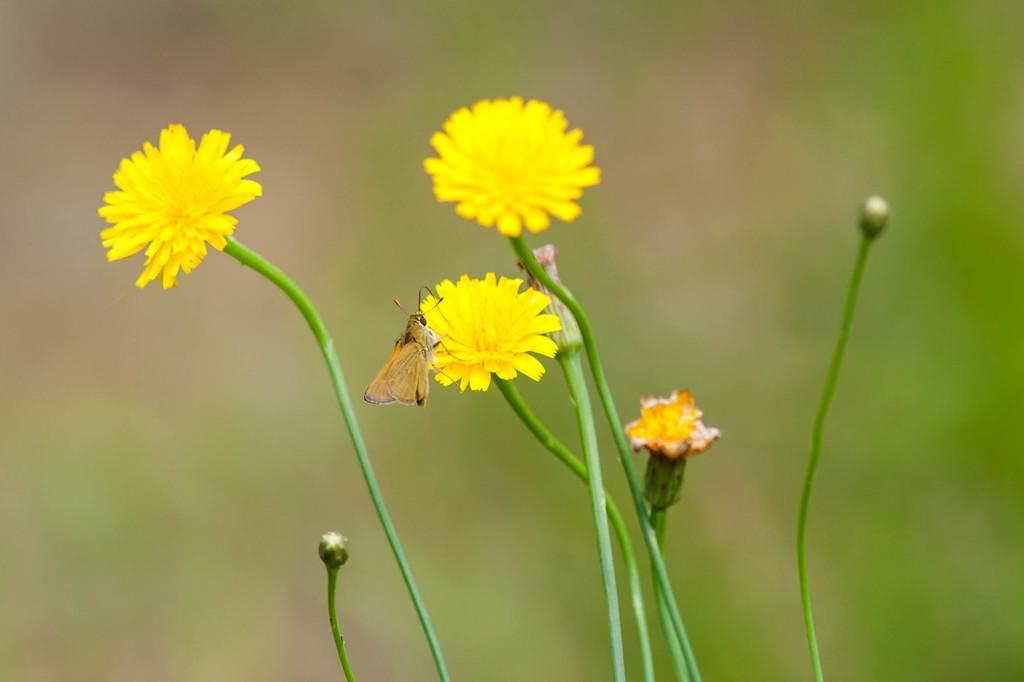What type of plant life can be seen in the image? There are flowers and buds in the image. Are there any living creatures present in the image? Yes, there is an insect in the image. How would you describe the background of the image? The background of the image is blurred. What type of feather can be seen on the mother's hat in the image? There is no mother or hat present in the image; it features flowers, buds, and an insect. 